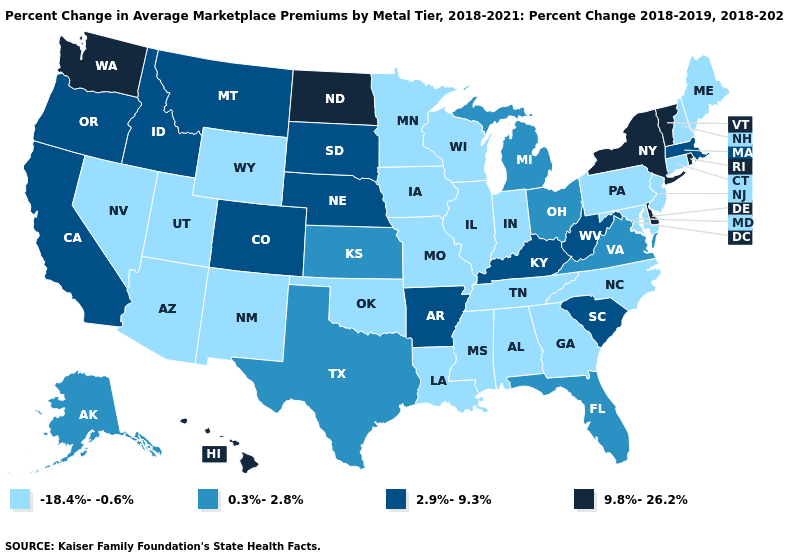Name the states that have a value in the range -18.4%--0.6%?
Keep it brief. Alabama, Arizona, Connecticut, Georgia, Illinois, Indiana, Iowa, Louisiana, Maine, Maryland, Minnesota, Mississippi, Missouri, Nevada, New Hampshire, New Jersey, New Mexico, North Carolina, Oklahoma, Pennsylvania, Tennessee, Utah, Wisconsin, Wyoming. Is the legend a continuous bar?
Be succinct. No. What is the value of Utah?
Keep it brief. -18.4%--0.6%. Name the states that have a value in the range 9.8%-26.2%?
Keep it brief. Delaware, Hawaii, New York, North Dakota, Rhode Island, Vermont, Washington. Is the legend a continuous bar?
Keep it brief. No. Does Louisiana have a lower value than Kentucky?
Keep it brief. Yes. What is the value of Kansas?
Quick response, please. 0.3%-2.8%. Among the states that border Kentucky , which have the highest value?
Short answer required. West Virginia. Name the states that have a value in the range -18.4%--0.6%?
Keep it brief. Alabama, Arizona, Connecticut, Georgia, Illinois, Indiana, Iowa, Louisiana, Maine, Maryland, Minnesota, Mississippi, Missouri, Nevada, New Hampshire, New Jersey, New Mexico, North Carolina, Oklahoma, Pennsylvania, Tennessee, Utah, Wisconsin, Wyoming. What is the value of Hawaii?
Be succinct. 9.8%-26.2%. What is the highest value in states that border Oklahoma?
Be succinct. 2.9%-9.3%. What is the highest value in the South ?
Answer briefly. 9.8%-26.2%. What is the value of Louisiana?
Answer briefly. -18.4%--0.6%. What is the value of Michigan?
Keep it brief. 0.3%-2.8%. What is the value of Maryland?
Answer briefly. -18.4%--0.6%. 